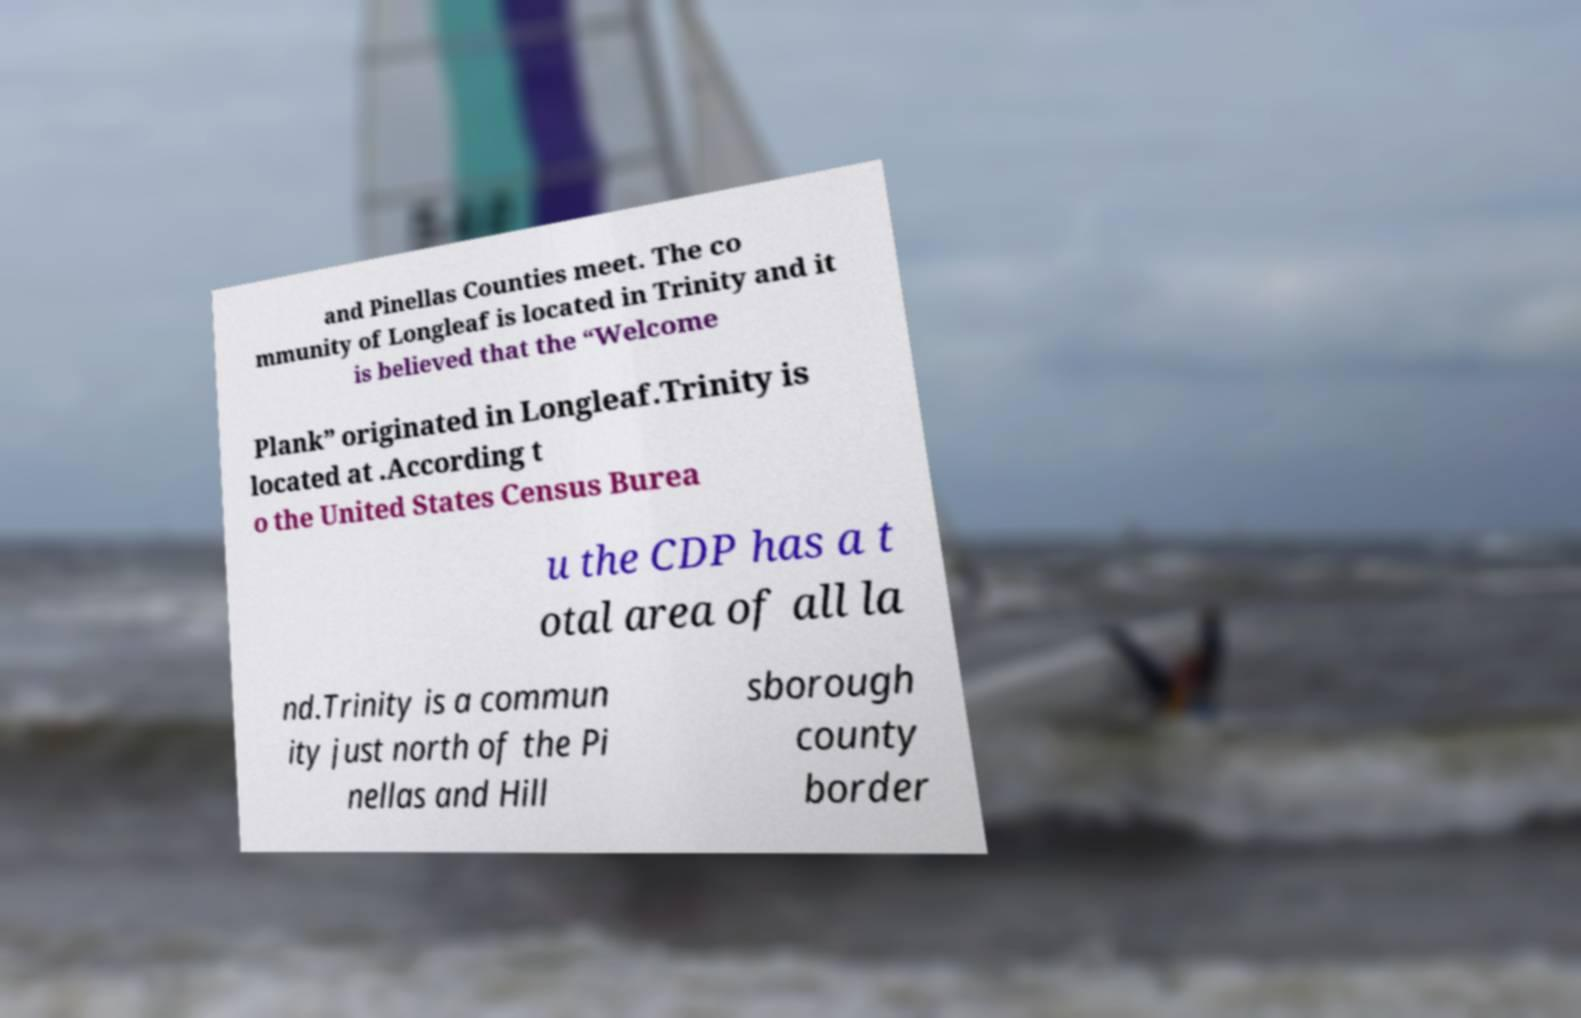Please identify and transcribe the text found in this image. and Pinellas Counties meet. The co mmunity of Longleaf is located in Trinity and it is believed that the “Welcome Plank” originated in Longleaf.Trinity is located at .According t o the United States Census Burea u the CDP has a t otal area of all la nd.Trinity is a commun ity just north of the Pi nellas and Hill sborough county border 